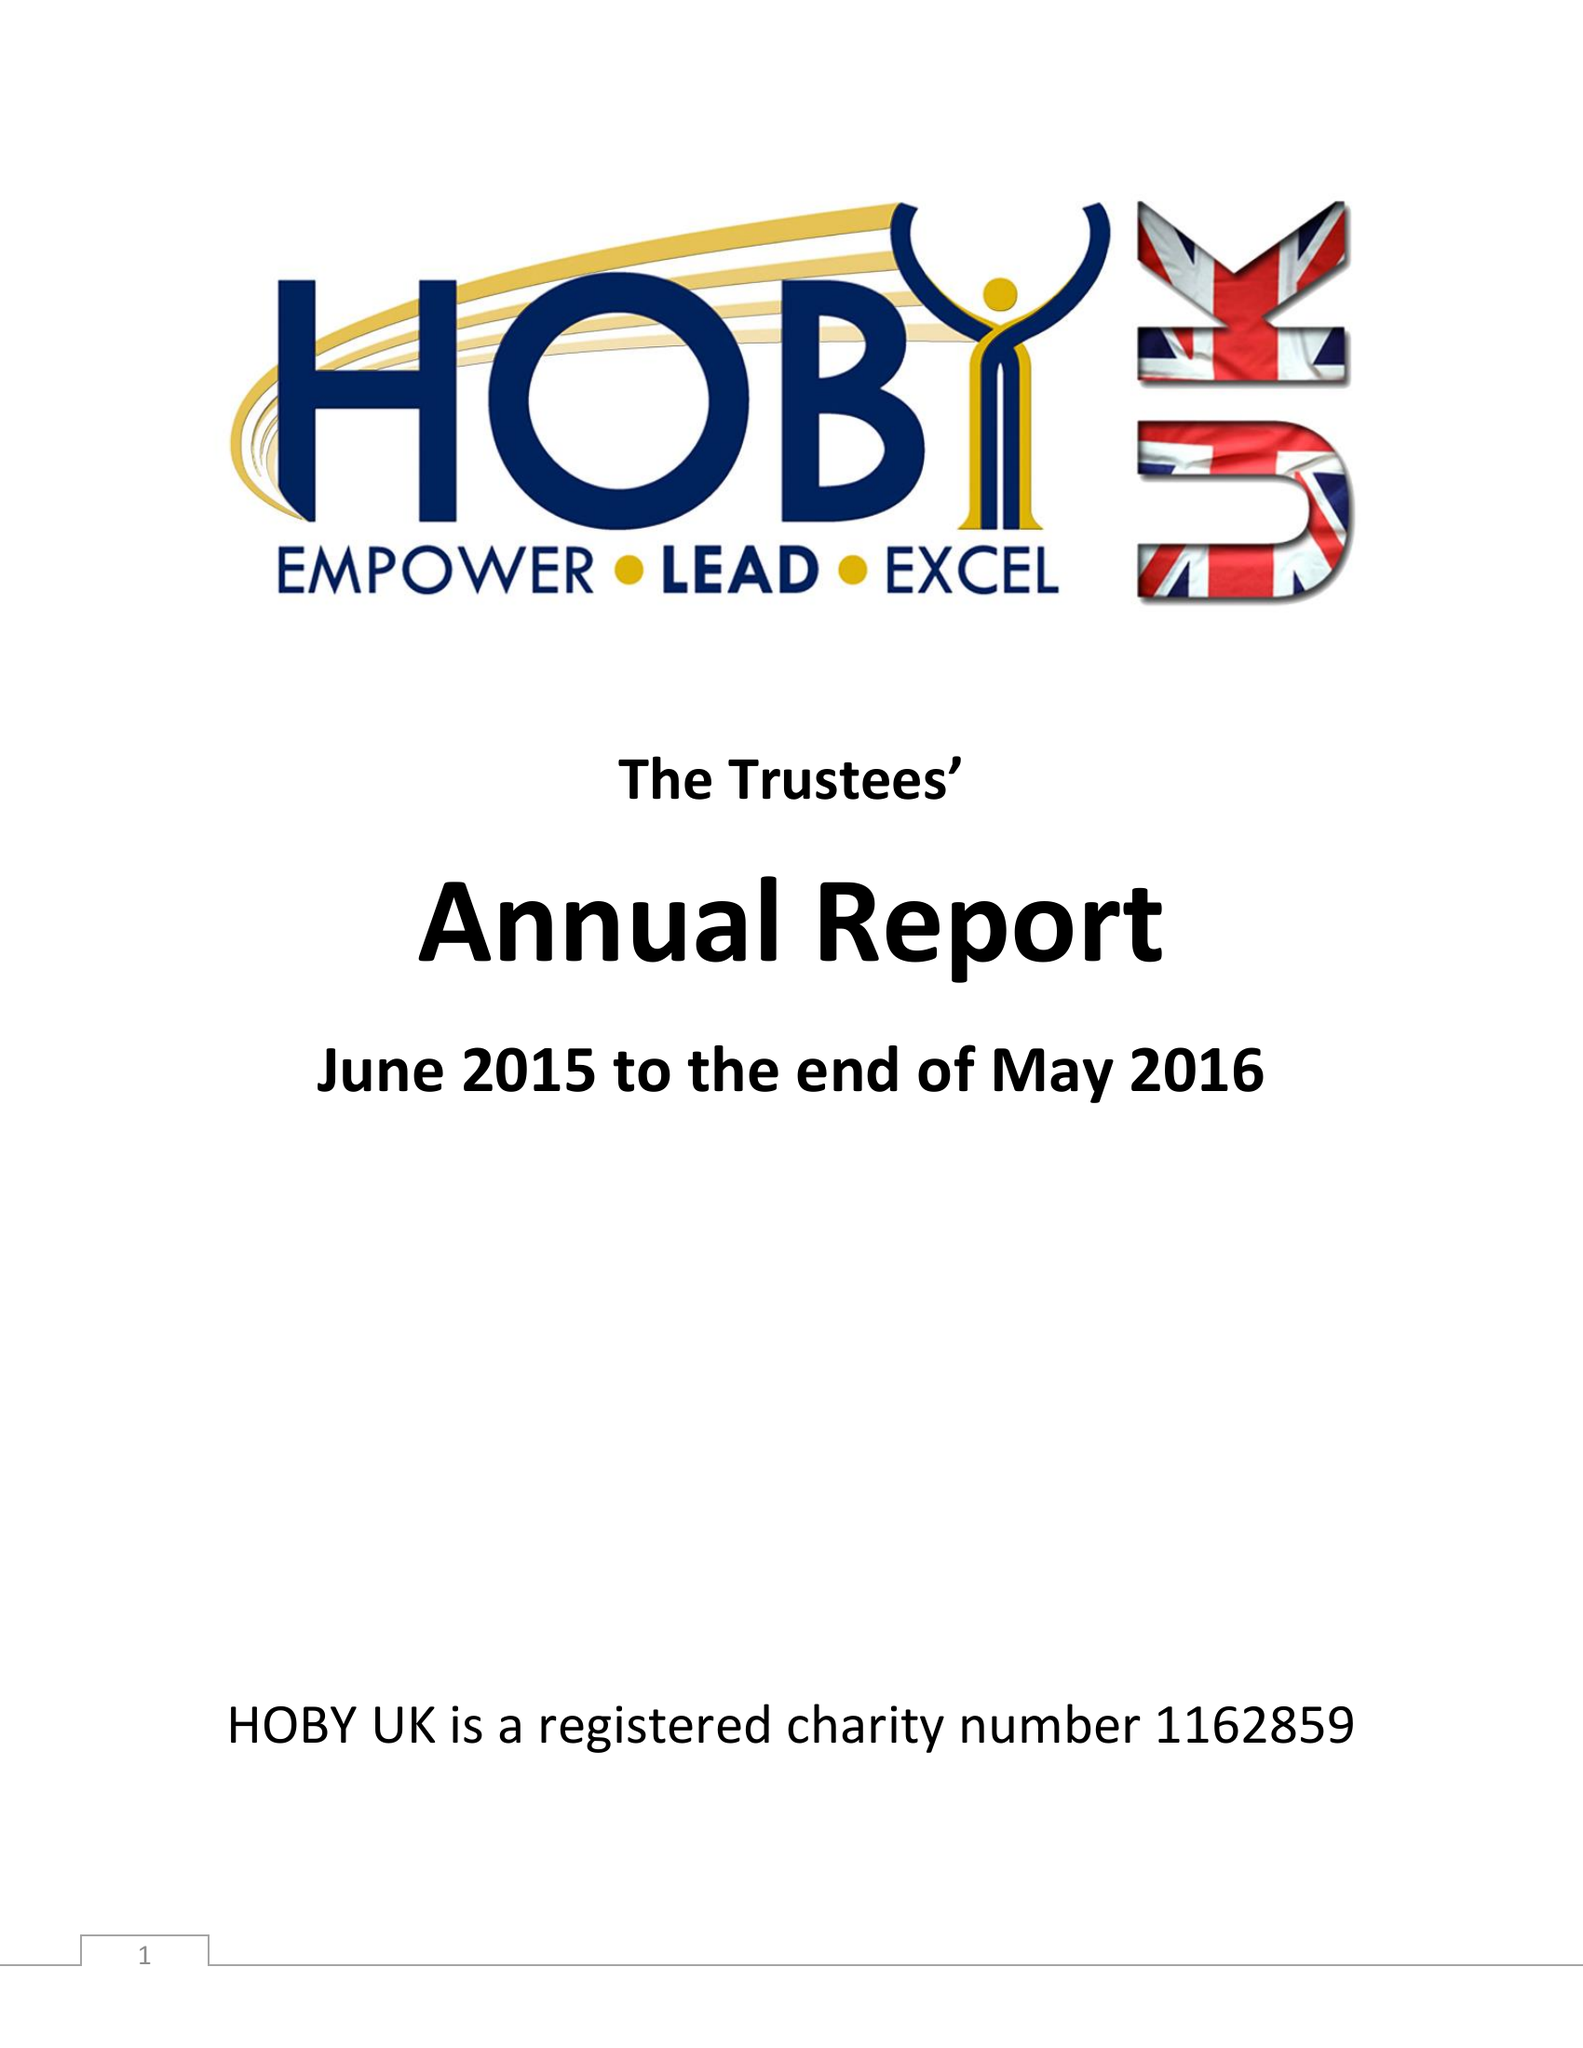What is the value for the income_annually_in_british_pounds?
Answer the question using a single word or phrase. 15231.00 